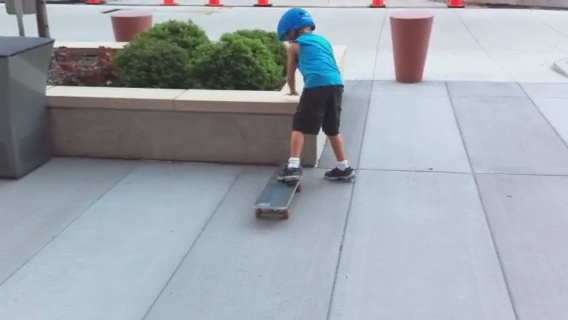Describe the objects in this image and their specific colors. I can see people in gray, black, teal, and lightblue tones and skateboard in gray tones in this image. 